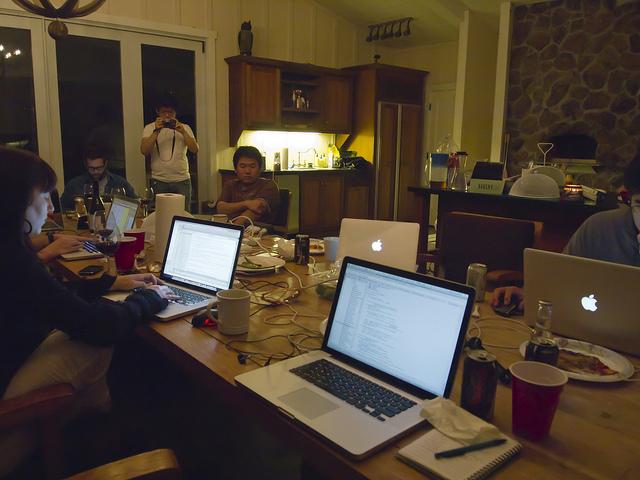What brand of laptops are being used?
Be succinct. Apple. How many devices does she appear to be using?
Quick response, please. 1. Are there people in the room?
Quick response, please. Yes. Does this look like it is going to be recycled?
Give a very brief answer. No. Why are there numerous laptops on the table?
Keep it brief. Internet cafe. Are there items on the counter?
Give a very brief answer. Yes. 